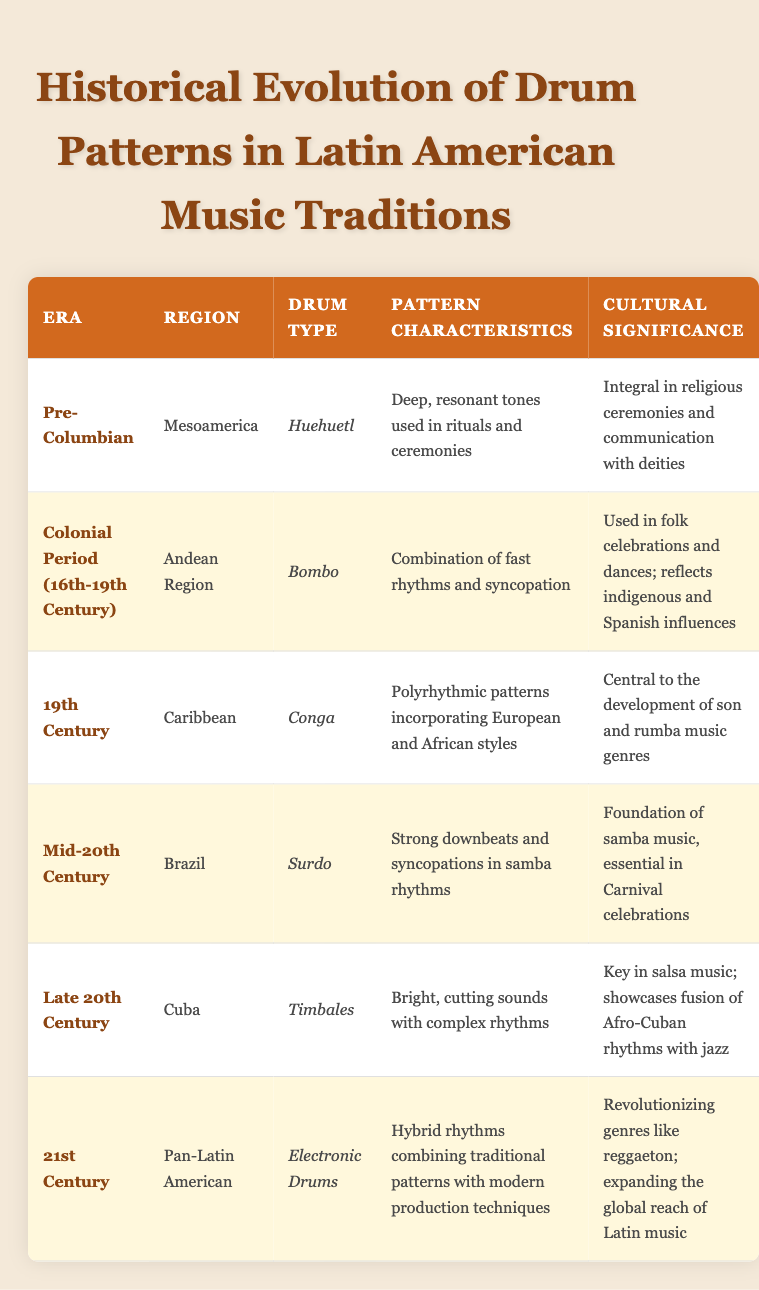What type of drum was used in the Pre-Columbian era? In the Pre-Columbian era, the drum type listed is Huehuetl. This can be directly seen in the table under the "Drum Type" column for the corresponding era.
Answer: Huehuetl Which region is associated with the Surdo drum? The region associated with the Surdo drum is Brazil, which is clearly indicated in the "Region" column for the entry listing the Surdo.
Answer: Brazil Did the Bombo drum combine influences from both indigenous and Spanish traditions? Yes, the cultural significance of the Bombo mentions that it reflects both indigenous and Spanish influences, confirming the presence of both in its development.
Answer: Yes Which drum patterns developed in the 19th century Caribbean are central to specific music genres? The Conga drum patterns in the 19th century Caribbean are characterized as polyrhythmic patterns central to the development of son and rumba music genres.
Answer: Conga How many different eras are represented in the table? There are six rows in the table, each corresponding to a different era: Pre-Columbian, Colonial Period, 19th Century, Mid-20th Century, Late 20th Century, and 21st Century. Therefore, there are six different eras represented.
Answer: 6 What is the cultural significance of Timbales in the Late 20th Century? The Timbales are identified in the table as key in salsa music and as a showcase of the fusion between Afro-Cuban rhythms and jazz during the Late 20th Century.
Answer: Key in salsa music What pattern characteristics differentiate the Surdo and Conga drums? The Surdo is noted for strong downbeats and syncopations in samba rhythms, while the Conga features polyrhythmic patterns incorporating European and African styles. The differences are highlighted in the "Pattern Characteristics" for each.
Answer: Strong downbeats and syncopations; Polyrhythmic patterns What hybrid innovation in drum patterns emerged in the 21st century? The 21st century saw the emergence of Electronic Drums, which feature hybrid rhythms that combine traditional patterns with modern production techniques as indicated in the table.
Answer: Electronic Drums Is the Huehuetl drum still relevant in modern music? Based on the table, the Huehuetl is not listed in any modern context, suggesting that its use may be mostly historical and not prominently relevant in contemporary music genres.
Answer: No 